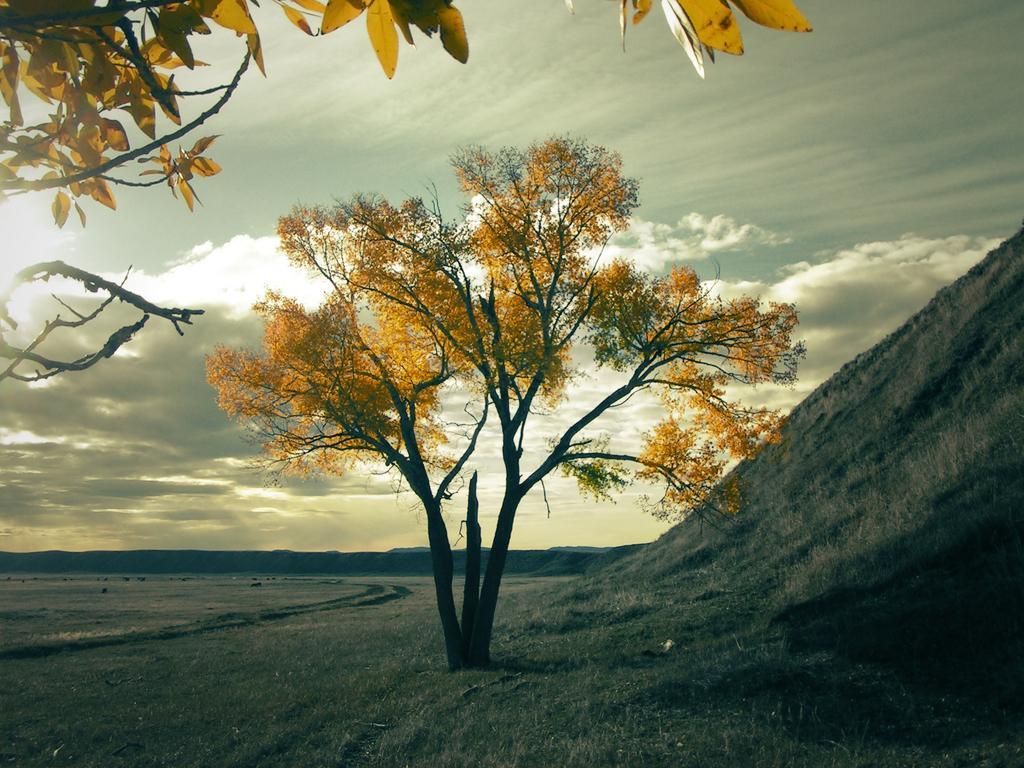How would you summarize this image in a sentence or two? In this image we can see a land and a tree. Behind the tree sky with cloud is present 